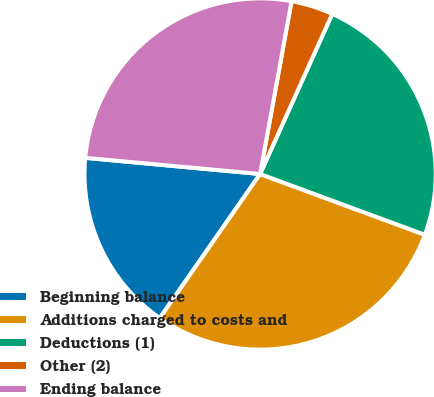<chart> <loc_0><loc_0><loc_500><loc_500><pie_chart><fcel>Beginning balance<fcel>Additions charged to costs and<fcel>Deductions (1)<fcel>Other (2)<fcel>Ending balance<nl><fcel>16.79%<fcel>29.05%<fcel>23.89%<fcel>3.87%<fcel>26.4%<nl></chart> 